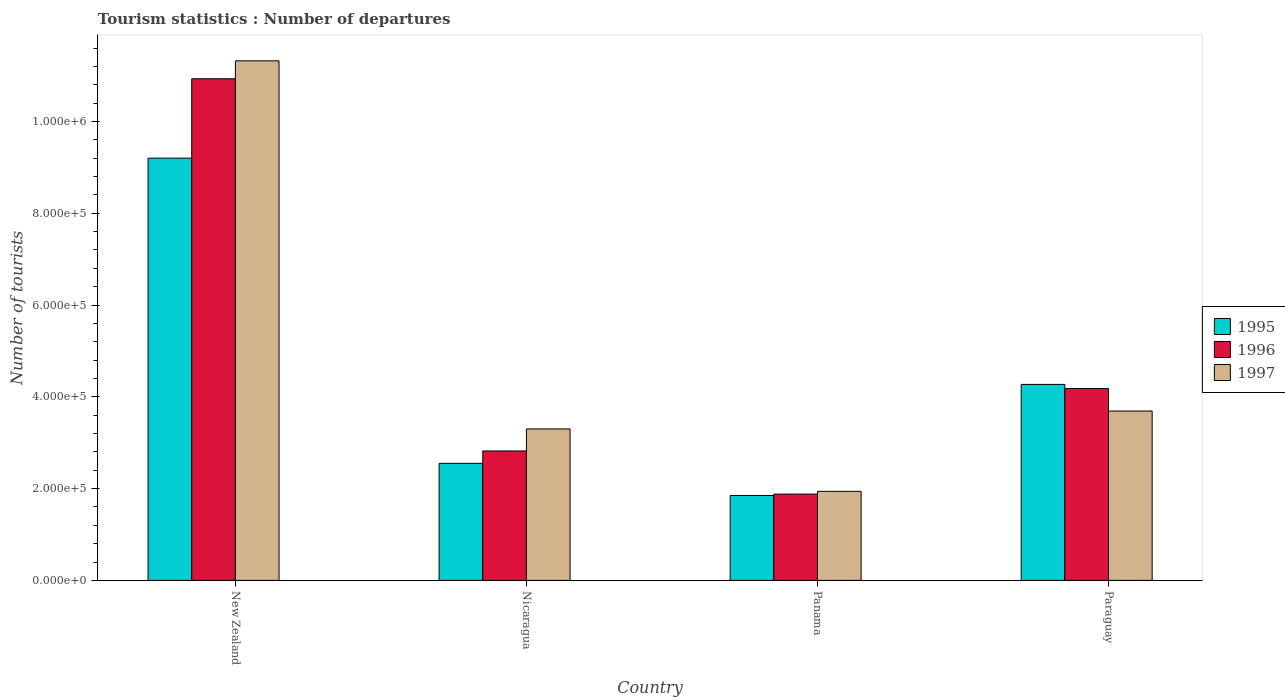How many different coloured bars are there?
Offer a terse response. 3. How many groups of bars are there?
Keep it short and to the point. 4. Are the number of bars on each tick of the X-axis equal?
Ensure brevity in your answer.  Yes. What is the label of the 1st group of bars from the left?
Ensure brevity in your answer.  New Zealand. What is the number of tourist departures in 1997 in Panama?
Ensure brevity in your answer.  1.94e+05. Across all countries, what is the maximum number of tourist departures in 1995?
Offer a terse response. 9.20e+05. Across all countries, what is the minimum number of tourist departures in 1995?
Your answer should be very brief. 1.85e+05. In which country was the number of tourist departures in 1996 maximum?
Make the answer very short. New Zealand. In which country was the number of tourist departures in 1995 minimum?
Your answer should be compact. Panama. What is the total number of tourist departures in 1997 in the graph?
Your answer should be very brief. 2.02e+06. What is the difference between the number of tourist departures in 1996 in New Zealand and that in Panama?
Give a very brief answer. 9.05e+05. What is the difference between the number of tourist departures in 1996 in New Zealand and the number of tourist departures in 1997 in Nicaragua?
Provide a succinct answer. 7.63e+05. What is the average number of tourist departures in 1996 per country?
Make the answer very short. 4.95e+05. What is the difference between the number of tourist departures of/in 1997 and number of tourist departures of/in 1996 in Nicaragua?
Ensure brevity in your answer.  4.80e+04. What is the ratio of the number of tourist departures in 1997 in Nicaragua to that in Panama?
Make the answer very short. 1.7. What is the difference between the highest and the second highest number of tourist departures in 1997?
Keep it short and to the point. 8.02e+05. What is the difference between the highest and the lowest number of tourist departures in 1996?
Your response must be concise. 9.05e+05. What does the 2nd bar from the left in Nicaragua represents?
Make the answer very short. 1996. Is it the case that in every country, the sum of the number of tourist departures in 1997 and number of tourist departures in 1995 is greater than the number of tourist departures in 1996?
Your response must be concise. Yes. Are all the bars in the graph horizontal?
Give a very brief answer. No. How many countries are there in the graph?
Ensure brevity in your answer.  4. Are the values on the major ticks of Y-axis written in scientific E-notation?
Your answer should be compact. Yes. How many legend labels are there?
Offer a very short reply. 3. How are the legend labels stacked?
Give a very brief answer. Vertical. What is the title of the graph?
Your response must be concise. Tourism statistics : Number of departures. What is the label or title of the Y-axis?
Provide a short and direct response. Number of tourists. What is the Number of tourists in 1995 in New Zealand?
Give a very brief answer. 9.20e+05. What is the Number of tourists in 1996 in New Zealand?
Make the answer very short. 1.09e+06. What is the Number of tourists of 1997 in New Zealand?
Provide a succinct answer. 1.13e+06. What is the Number of tourists of 1995 in Nicaragua?
Your answer should be very brief. 2.55e+05. What is the Number of tourists of 1996 in Nicaragua?
Make the answer very short. 2.82e+05. What is the Number of tourists in 1995 in Panama?
Your answer should be very brief. 1.85e+05. What is the Number of tourists in 1996 in Panama?
Your response must be concise. 1.88e+05. What is the Number of tourists in 1997 in Panama?
Provide a succinct answer. 1.94e+05. What is the Number of tourists in 1995 in Paraguay?
Make the answer very short. 4.27e+05. What is the Number of tourists in 1996 in Paraguay?
Give a very brief answer. 4.18e+05. What is the Number of tourists in 1997 in Paraguay?
Your response must be concise. 3.69e+05. Across all countries, what is the maximum Number of tourists in 1995?
Your response must be concise. 9.20e+05. Across all countries, what is the maximum Number of tourists of 1996?
Your answer should be very brief. 1.09e+06. Across all countries, what is the maximum Number of tourists in 1997?
Ensure brevity in your answer.  1.13e+06. Across all countries, what is the minimum Number of tourists of 1995?
Make the answer very short. 1.85e+05. Across all countries, what is the minimum Number of tourists of 1996?
Ensure brevity in your answer.  1.88e+05. Across all countries, what is the minimum Number of tourists of 1997?
Offer a terse response. 1.94e+05. What is the total Number of tourists in 1995 in the graph?
Your response must be concise. 1.79e+06. What is the total Number of tourists in 1996 in the graph?
Keep it short and to the point. 1.98e+06. What is the total Number of tourists of 1997 in the graph?
Your response must be concise. 2.02e+06. What is the difference between the Number of tourists of 1995 in New Zealand and that in Nicaragua?
Provide a short and direct response. 6.65e+05. What is the difference between the Number of tourists of 1996 in New Zealand and that in Nicaragua?
Keep it short and to the point. 8.11e+05. What is the difference between the Number of tourists in 1997 in New Zealand and that in Nicaragua?
Provide a succinct answer. 8.02e+05. What is the difference between the Number of tourists in 1995 in New Zealand and that in Panama?
Provide a short and direct response. 7.35e+05. What is the difference between the Number of tourists of 1996 in New Zealand and that in Panama?
Provide a succinct answer. 9.05e+05. What is the difference between the Number of tourists of 1997 in New Zealand and that in Panama?
Your answer should be compact. 9.38e+05. What is the difference between the Number of tourists in 1995 in New Zealand and that in Paraguay?
Your answer should be very brief. 4.93e+05. What is the difference between the Number of tourists of 1996 in New Zealand and that in Paraguay?
Offer a very short reply. 6.75e+05. What is the difference between the Number of tourists of 1997 in New Zealand and that in Paraguay?
Provide a succinct answer. 7.63e+05. What is the difference between the Number of tourists in 1995 in Nicaragua and that in Panama?
Make the answer very short. 7.00e+04. What is the difference between the Number of tourists in 1996 in Nicaragua and that in Panama?
Provide a succinct answer. 9.40e+04. What is the difference between the Number of tourists in 1997 in Nicaragua and that in Panama?
Offer a very short reply. 1.36e+05. What is the difference between the Number of tourists in 1995 in Nicaragua and that in Paraguay?
Provide a short and direct response. -1.72e+05. What is the difference between the Number of tourists in 1996 in Nicaragua and that in Paraguay?
Your response must be concise. -1.36e+05. What is the difference between the Number of tourists of 1997 in Nicaragua and that in Paraguay?
Your answer should be very brief. -3.90e+04. What is the difference between the Number of tourists of 1995 in Panama and that in Paraguay?
Offer a very short reply. -2.42e+05. What is the difference between the Number of tourists in 1996 in Panama and that in Paraguay?
Your answer should be very brief. -2.30e+05. What is the difference between the Number of tourists of 1997 in Panama and that in Paraguay?
Keep it short and to the point. -1.75e+05. What is the difference between the Number of tourists in 1995 in New Zealand and the Number of tourists in 1996 in Nicaragua?
Provide a short and direct response. 6.38e+05. What is the difference between the Number of tourists of 1995 in New Zealand and the Number of tourists of 1997 in Nicaragua?
Make the answer very short. 5.90e+05. What is the difference between the Number of tourists in 1996 in New Zealand and the Number of tourists in 1997 in Nicaragua?
Keep it short and to the point. 7.63e+05. What is the difference between the Number of tourists in 1995 in New Zealand and the Number of tourists in 1996 in Panama?
Your answer should be compact. 7.32e+05. What is the difference between the Number of tourists of 1995 in New Zealand and the Number of tourists of 1997 in Panama?
Your answer should be very brief. 7.26e+05. What is the difference between the Number of tourists in 1996 in New Zealand and the Number of tourists in 1997 in Panama?
Give a very brief answer. 8.99e+05. What is the difference between the Number of tourists in 1995 in New Zealand and the Number of tourists in 1996 in Paraguay?
Your answer should be compact. 5.02e+05. What is the difference between the Number of tourists of 1995 in New Zealand and the Number of tourists of 1997 in Paraguay?
Provide a short and direct response. 5.51e+05. What is the difference between the Number of tourists of 1996 in New Zealand and the Number of tourists of 1997 in Paraguay?
Keep it short and to the point. 7.24e+05. What is the difference between the Number of tourists of 1995 in Nicaragua and the Number of tourists of 1996 in Panama?
Your answer should be compact. 6.70e+04. What is the difference between the Number of tourists of 1995 in Nicaragua and the Number of tourists of 1997 in Panama?
Your answer should be compact. 6.10e+04. What is the difference between the Number of tourists in 1996 in Nicaragua and the Number of tourists in 1997 in Panama?
Make the answer very short. 8.80e+04. What is the difference between the Number of tourists of 1995 in Nicaragua and the Number of tourists of 1996 in Paraguay?
Provide a short and direct response. -1.63e+05. What is the difference between the Number of tourists of 1995 in Nicaragua and the Number of tourists of 1997 in Paraguay?
Your answer should be compact. -1.14e+05. What is the difference between the Number of tourists of 1996 in Nicaragua and the Number of tourists of 1997 in Paraguay?
Make the answer very short. -8.70e+04. What is the difference between the Number of tourists of 1995 in Panama and the Number of tourists of 1996 in Paraguay?
Your response must be concise. -2.33e+05. What is the difference between the Number of tourists of 1995 in Panama and the Number of tourists of 1997 in Paraguay?
Offer a very short reply. -1.84e+05. What is the difference between the Number of tourists in 1996 in Panama and the Number of tourists in 1997 in Paraguay?
Offer a very short reply. -1.81e+05. What is the average Number of tourists of 1995 per country?
Your response must be concise. 4.47e+05. What is the average Number of tourists of 1996 per country?
Provide a short and direct response. 4.95e+05. What is the average Number of tourists of 1997 per country?
Offer a very short reply. 5.06e+05. What is the difference between the Number of tourists in 1995 and Number of tourists in 1996 in New Zealand?
Offer a terse response. -1.73e+05. What is the difference between the Number of tourists in 1995 and Number of tourists in 1997 in New Zealand?
Your answer should be compact. -2.12e+05. What is the difference between the Number of tourists of 1996 and Number of tourists of 1997 in New Zealand?
Provide a short and direct response. -3.90e+04. What is the difference between the Number of tourists in 1995 and Number of tourists in 1996 in Nicaragua?
Your response must be concise. -2.70e+04. What is the difference between the Number of tourists in 1995 and Number of tourists in 1997 in Nicaragua?
Offer a terse response. -7.50e+04. What is the difference between the Number of tourists of 1996 and Number of tourists of 1997 in Nicaragua?
Your answer should be very brief. -4.80e+04. What is the difference between the Number of tourists in 1995 and Number of tourists in 1996 in Panama?
Your answer should be very brief. -3000. What is the difference between the Number of tourists in 1995 and Number of tourists in 1997 in Panama?
Your response must be concise. -9000. What is the difference between the Number of tourists in 1996 and Number of tourists in 1997 in Panama?
Your answer should be very brief. -6000. What is the difference between the Number of tourists of 1995 and Number of tourists of 1996 in Paraguay?
Give a very brief answer. 9000. What is the difference between the Number of tourists of 1995 and Number of tourists of 1997 in Paraguay?
Provide a succinct answer. 5.80e+04. What is the difference between the Number of tourists of 1996 and Number of tourists of 1997 in Paraguay?
Make the answer very short. 4.90e+04. What is the ratio of the Number of tourists in 1995 in New Zealand to that in Nicaragua?
Offer a very short reply. 3.61. What is the ratio of the Number of tourists in 1996 in New Zealand to that in Nicaragua?
Your response must be concise. 3.88. What is the ratio of the Number of tourists in 1997 in New Zealand to that in Nicaragua?
Ensure brevity in your answer.  3.43. What is the ratio of the Number of tourists in 1995 in New Zealand to that in Panama?
Provide a short and direct response. 4.97. What is the ratio of the Number of tourists of 1996 in New Zealand to that in Panama?
Make the answer very short. 5.81. What is the ratio of the Number of tourists in 1997 in New Zealand to that in Panama?
Make the answer very short. 5.84. What is the ratio of the Number of tourists of 1995 in New Zealand to that in Paraguay?
Your answer should be compact. 2.15. What is the ratio of the Number of tourists of 1996 in New Zealand to that in Paraguay?
Give a very brief answer. 2.61. What is the ratio of the Number of tourists of 1997 in New Zealand to that in Paraguay?
Ensure brevity in your answer.  3.07. What is the ratio of the Number of tourists of 1995 in Nicaragua to that in Panama?
Offer a very short reply. 1.38. What is the ratio of the Number of tourists in 1997 in Nicaragua to that in Panama?
Provide a succinct answer. 1.7. What is the ratio of the Number of tourists in 1995 in Nicaragua to that in Paraguay?
Offer a very short reply. 0.6. What is the ratio of the Number of tourists of 1996 in Nicaragua to that in Paraguay?
Keep it short and to the point. 0.67. What is the ratio of the Number of tourists of 1997 in Nicaragua to that in Paraguay?
Offer a terse response. 0.89. What is the ratio of the Number of tourists of 1995 in Panama to that in Paraguay?
Your answer should be very brief. 0.43. What is the ratio of the Number of tourists in 1996 in Panama to that in Paraguay?
Your response must be concise. 0.45. What is the ratio of the Number of tourists of 1997 in Panama to that in Paraguay?
Ensure brevity in your answer.  0.53. What is the difference between the highest and the second highest Number of tourists in 1995?
Ensure brevity in your answer.  4.93e+05. What is the difference between the highest and the second highest Number of tourists in 1996?
Provide a succinct answer. 6.75e+05. What is the difference between the highest and the second highest Number of tourists of 1997?
Your answer should be compact. 7.63e+05. What is the difference between the highest and the lowest Number of tourists of 1995?
Ensure brevity in your answer.  7.35e+05. What is the difference between the highest and the lowest Number of tourists in 1996?
Your answer should be very brief. 9.05e+05. What is the difference between the highest and the lowest Number of tourists in 1997?
Ensure brevity in your answer.  9.38e+05. 